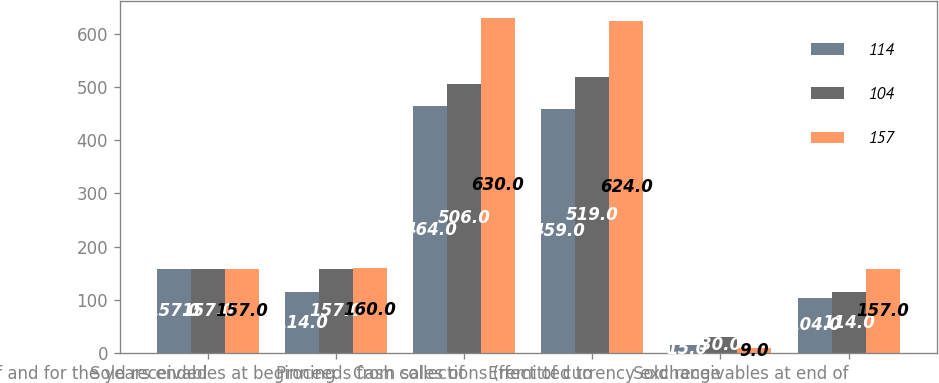Convert chart. <chart><loc_0><loc_0><loc_500><loc_500><stacked_bar_chart><ecel><fcel>as of and for the years ended<fcel>Sold receivables at beginning<fcel>Proceeds from sales of<fcel>Cash collections (remitted to<fcel>Effect of currency exchange<fcel>Sold receivables at end of<nl><fcel>114<fcel>157<fcel>114<fcel>464<fcel>459<fcel>15<fcel>104<nl><fcel>104<fcel>157<fcel>157<fcel>506<fcel>519<fcel>30<fcel>114<nl><fcel>157<fcel>157<fcel>160<fcel>630<fcel>624<fcel>9<fcel>157<nl></chart> 